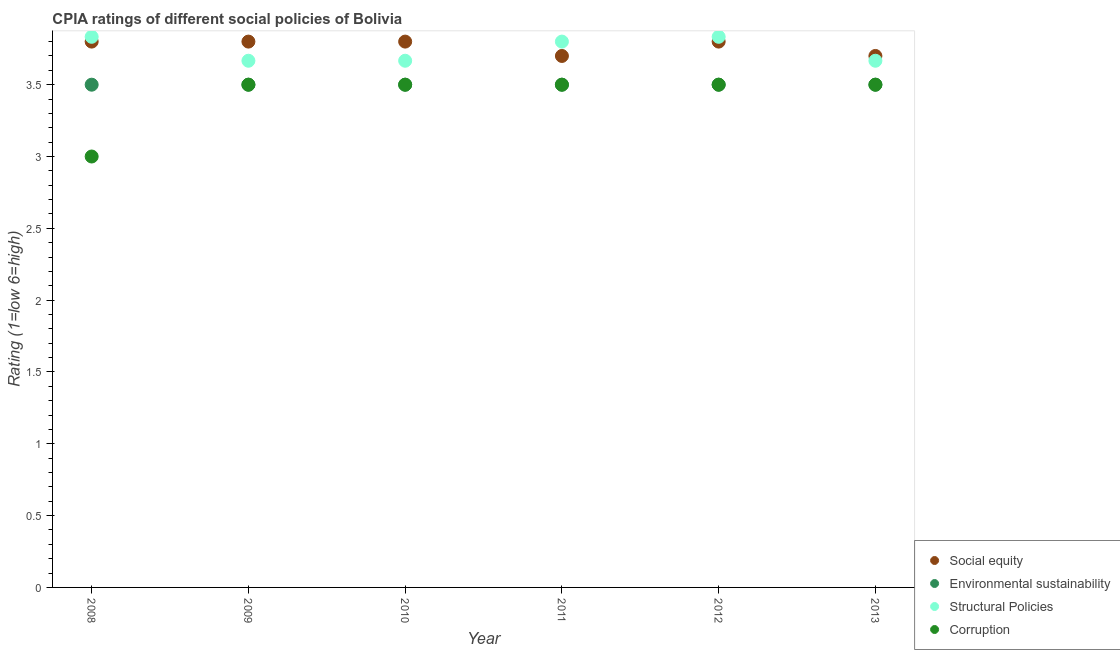Is the number of dotlines equal to the number of legend labels?
Your response must be concise. Yes. Across all years, what is the maximum cpia rating of social equity?
Keep it short and to the point. 3.8. What is the total cpia rating of environmental sustainability in the graph?
Your answer should be compact. 21. What is the difference between the cpia rating of environmental sustainability in 2011 and that in 2013?
Provide a succinct answer. 0. What is the average cpia rating of structural policies per year?
Keep it short and to the point. 3.74. In the year 2010, what is the difference between the cpia rating of structural policies and cpia rating of environmental sustainability?
Ensure brevity in your answer.  0.17. In how many years, is the cpia rating of environmental sustainability greater than 2.5?
Your answer should be compact. 6. What is the ratio of the cpia rating of corruption in 2009 to that in 2011?
Provide a short and direct response. 1. Is the cpia rating of environmental sustainability in 2011 less than that in 2013?
Your response must be concise. No. What is the difference between the highest and the second highest cpia rating of environmental sustainability?
Make the answer very short. 0. In how many years, is the cpia rating of corruption greater than the average cpia rating of corruption taken over all years?
Your answer should be compact. 5. Is the sum of the cpia rating of corruption in 2008 and 2012 greater than the maximum cpia rating of social equity across all years?
Keep it short and to the point. Yes. Is it the case that in every year, the sum of the cpia rating of environmental sustainability and cpia rating of structural policies is greater than the sum of cpia rating of corruption and cpia rating of social equity?
Offer a very short reply. No. Is the cpia rating of environmental sustainability strictly greater than the cpia rating of social equity over the years?
Offer a very short reply. No. Is the cpia rating of social equity strictly less than the cpia rating of structural policies over the years?
Your response must be concise. No. How many years are there in the graph?
Your response must be concise. 6. What is the difference between two consecutive major ticks on the Y-axis?
Offer a very short reply. 0.5. Does the graph contain any zero values?
Make the answer very short. No. Does the graph contain grids?
Give a very brief answer. No. How are the legend labels stacked?
Your answer should be compact. Vertical. What is the title of the graph?
Keep it short and to the point. CPIA ratings of different social policies of Bolivia. Does "Primary schools" appear as one of the legend labels in the graph?
Ensure brevity in your answer.  No. What is the Rating (1=low 6=high) in Social equity in 2008?
Provide a succinct answer. 3.8. What is the Rating (1=low 6=high) of Structural Policies in 2008?
Make the answer very short. 3.83. What is the Rating (1=low 6=high) of Social equity in 2009?
Offer a very short reply. 3.8. What is the Rating (1=low 6=high) of Environmental sustainability in 2009?
Make the answer very short. 3.5. What is the Rating (1=low 6=high) in Structural Policies in 2009?
Offer a very short reply. 3.67. What is the Rating (1=low 6=high) in Structural Policies in 2010?
Your response must be concise. 3.67. What is the Rating (1=low 6=high) in Social equity in 2011?
Provide a short and direct response. 3.7. What is the Rating (1=low 6=high) of Environmental sustainability in 2011?
Ensure brevity in your answer.  3.5. What is the Rating (1=low 6=high) in Social equity in 2012?
Your answer should be very brief. 3.8. What is the Rating (1=low 6=high) of Structural Policies in 2012?
Ensure brevity in your answer.  3.83. What is the Rating (1=low 6=high) of Environmental sustainability in 2013?
Keep it short and to the point. 3.5. What is the Rating (1=low 6=high) in Structural Policies in 2013?
Provide a short and direct response. 3.67. Across all years, what is the maximum Rating (1=low 6=high) of Social equity?
Your answer should be very brief. 3.8. Across all years, what is the maximum Rating (1=low 6=high) in Structural Policies?
Provide a short and direct response. 3.83. Across all years, what is the minimum Rating (1=low 6=high) of Structural Policies?
Provide a succinct answer. 3.67. What is the total Rating (1=low 6=high) of Social equity in the graph?
Your answer should be very brief. 22.6. What is the total Rating (1=low 6=high) in Environmental sustainability in the graph?
Your answer should be compact. 21. What is the total Rating (1=low 6=high) in Structural Policies in the graph?
Provide a succinct answer. 22.47. What is the total Rating (1=low 6=high) in Corruption in the graph?
Keep it short and to the point. 20.5. What is the difference between the Rating (1=low 6=high) in Corruption in 2008 and that in 2009?
Provide a short and direct response. -0.5. What is the difference between the Rating (1=low 6=high) in Corruption in 2008 and that in 2010?
Make the answer very short. -0.5. What is the difference between the Rating (1=low 6=high) in Environmental sustainability in 2008 and that in 2011?
Make the answer very short. 0. What is the difference between the Rating (1=low 6=high) of Environmental sustainability in 2008 and that in 2012?
Offer a terse response. 0. What is the difference between the Rating (1=low 6=high) in Structural Policies in 2008 and that in 2012?
Offer a very short reply. 0. What is the difference between the Rating (1=low 6=high) in Social equity in 2008 and that in 2013?
Provide a short and direct response. 0.1. What is the difference between the Rating (1=low 6=high) of Environmental sustainability in 2008 and that in 2013?
Give a very brief answer. 0. What is the difference between the Rating (1=low 6=high) of Structural Policies in 2009 and that in 2010?
Ensure brevity in your answer.  0. What is the difference between the Rating (1=low 6=high) of Corruption in 2009 and that in 2010?
Your response must be concise. 0. What is the difference between the Rating (1=low 6=high) in Social equity in 2009 and that in 2011?
Offer a terse response. 0.1. What is the difference between the Rating (1=low 6=high) of Environmental sustainability in 2009 and that in 2011?
Ensure brevity in your answer.  0. What is the difference between the Rating (1=low 6=high) in Structural Policies in 2009 and that in 2011?
Provide a short and direct response. -0.13. What is the difference between the Rating (1=low 6=high) of Corruption in 2009 and that in 2012?
Give a very brief answer. 0. What is the difference between the Rating (1=low 6=high) of Structural Policies in 2009 and that in 2013?
Your answer should be very brief. 0. What is the difference between the Rating (1=low 6=high) in Corruption in 2009 and that in 2013?
Your response must be concise. 0. What is the difference between the Rating (1=low 6=high) of Social equity in 2010 and that in 2011?
Provide a short and direct response. 0.1. What is the difference between the Rating (1=low 6=high) of Environmental sustainability in 2010 and that in 2011?
Your answer should be very brief. 0. What is the difference between the Rating (1=low 6=high) in Structural Policies in 2010 and that in 2011?
Your answer should be very brief. -0.13. What is the difference between the Rating (1=low 6=high) in Corruption in 2010 and that in 2011?
Keep it short and to the point. 0. What is the difference between the Rating (1=low 6=high) in Social equity in 2010 and that in 2012?
Your answer should be compact. 0. What is the difference between the Rating (1=low 6=high) of Environmental sustainability in 2010 and that in 2013?
Your answer should be very brief. 0. What is the difference between the Rating (1=low 6=high) in Structural Policies in 2010 and that in 2013?
Your response must be concise. 0. What is the difference between the Rating (1=low 6=high) in Corruption in 2010 and that in 2013?
Offer a terse response. 0. What is the difference between the Rating (1=low 6=high) in Social equity in 2011 and that in 2012?
Your response must be concise. -0.1. What is the difference between the Rating (1=low 6=high) of Structural Policies in 2011 and that in 2012?
Your answer should be very brief. -0.03. What is the difference between the Rating (1=low 6=high) in Corruption in 2011 and that in 2012?
Offer a terse response. 0. What is the difference between the Rating (1=low 6=high) of Environmental sustainability in 2011 and that in 2013?
Keep it short and to the point. 0. What is the difference between the Rating (1=low 6=high) of Structural Policies in 2011 and that in 2013?
Offer a very short reply. 0.13. What is the difference between the Rating (1=low 6=high) of Corruption in 2011 and that in 2013?
Offer a terse response. 0. What is the difference between the Rating (1=low 6=high) in Social equity in 2012 and that in 2013?
Ensure brevity in your answer.  0.1. What is the difference between the Rating (1=low 6=high) of Structural Policies in 2012 and that in 2013?
Provide a short and direct response. 0.17. What is the difference between the Rating (1=low 6=high) in Corruption in 2012 and that in 2013?
Your answer should be compact. 0. What is the difference between the Rating (1=low 6=high) of Social equity in 2008 and the Rating (1=low 6=high) of Structural Policies in 2009?
Provide a short and direct response. 0.13. What is the difference between the Rating (1=low 6=high) in Social equity in 2008 and the Rating (1=low 6=high) in Corruption in 2009?
Your answer should be very brief. 0.3. What is the difference between the Rating (1=low 6=high) of Social equity in 2008 and the Rating (1=low 6=high) of Structural Policies in 2010?
Keep it short and to the point. 0.13. What is the difference between the Rating (1=low 6=high) in Environmental sustainability in 2008 and the Rating (1=low 6=high) in Structural Policies in 2010?
Offer a terse response. -0.17. What is the difference between the Rating (1=low 6=high) in Social equity in 2008 and the Rating (1=low 6=high) in Corruption in 2011?
Ensure brevity in your answer.  0.3. What is the difference between the Rating (1=low 6=high) in Environmental sustainability in 2008 and the Rating (1=low 6=high) in Structural Policies in 2011?
Give a very brief answer. -0.3. What is the difference between the Rating (1=low 6=high) in Environmental sustainability in 2008 and the Rating (1=low 6=high) in Corruption in 2011?
Your answer should be compact. 0. What is the difference between the Rating (1=low 6=high) of Structural Policies in 2008 and the Rating (1=low 6=high) of Corruption in 2011?
Offer a terse response. 0.33. What is the difference between the Rating (1=low 6=high) of Social equity in 2008 and the Rating (1=low 6=high) of Structural Policies in 2012?
Make the answer very short. -0.03. What is the difference between the Rating (1=low 6=high) of Social equity in 2008 and the Rating (1=low 6=high) of Corruption in 2012?
Offer a terse response. 0.3. What is the difference between the Rating (1=low 6=high) in Environmental sustainability in 2008 and the Rating (1=low 6=high) in Structural Policies in 2012?
Make the answer very short. -0.33. What is the difference between the Rating (1=low 6=high) of Environmental sustainability in 2008 and the Rating (1=low 6=high) of Corruption in 2012?
Offer a very short reply. 0. What is the difference between the Rating (1=low 6=high) of Social equity in 2008 and the Rating (1=low 6=high) of Environmental sustainability in 2013?
Offer a terse response. 0.3. What is the difference between the Rating (1=low 6=high) in Social equity in 2008 and the Rating (1=low 6=high) in Structural Policies in 2013?
Your answer should be very brief. 0.13. What is the difference between the Rating (1=low 6=high) of Social equity in 2008 and the Rating (1=low 6=high) of Corruption in 2013?
Make the answer very short. 0.3. What is the difference between the Rating (1=low 6=high) of Environmental sustainability in 2008 and the Rating (1=low 6=high) of Structural Policies in 2013?
Keep it short and to the point. -0.17. What is the difference between the Rating (1=low 6=high) of Environmental sustainability in 2008 and the Rating (1=low 6=high) of Corruption in 2013?
Make the answer very short. 0. What is the difference between the Rating (1=low 6=high) of Social equity in 2009 and the Rating (1=low 6=high) of Environmental sustainability in 2010?
Make the answer very short. 0.3. What is the difference between the Rating (1=low 6=high) of Social equity in 2009 and the Rating (1=low 6=high) of Structural Policies in 2010?
Your answer should be compact. 0.13. What is the difference between the Rating (1=low 6=high) of Social equity in 2009 and the Rating (1=low 6=high) of Corruption in 2010?
Offer a very short reply. 0.3. What is the difference between the Rating (1=low 6=high) in Environmental sustainability in 2009 and the Rating (1=low 6=high) in Structural Policies in 2010?
Offer a terse response. -0.17. What is the difference between the Rating (1=low 6=high) in Environmental sustainability in 2009 and the Rating (1=low 6=high) in Corruption in 2011?
Provide a succinct answer. 0. What is the difference between the Rating (1=low 6=high) in Structural Policies in 2009 and the Rating (1=low 6=high) in Corruption in 2011?
Give a very brief answer. 0.17. What is the difference between the Rating (1=low 6=high) in Social equity in 2009 and the Rating (1=low 6=high) in Environmental sustainability in 2012?
Give a very brief answer. 0.3. What is the difference between the Rating (1=low 6=high) of Social equity in 2009 and the Rating (1=low 6=high) of Structural Policies in 2012?
Provide a short and direct response. -0.03. What is the difference between the Rating (1=low 6=high) of Environmental sustainability in 2009 and the Rating (1=low 6=high) of Structural Policies in 2012?
Offer a terse response. -0.33. What is the difference between the Rating (1=low 6=high) in Environmental sustainability in 2009 and the Rating (1=low 6=high) in Corruption in 2012?
Offer a terse response. 0. What is the difference between the Rating (1=low 6=high) of Social equity in 2009 and the Rating (1=low 6=high) of Environmental sustainability in 2013?
Provide a succinct answer. 0.3. What is the difference between the Rating (1=low 6=high) of Social equity in 2009 and the Rating (1=low 6=high) of Structural Policies in 2013?
Ensure brevity in your answer.  0.13. What is the difference between the Rating (1=low 6=high) of Social equity in 2009 and the Rating (1=low 6=high) of Corruption in 2013?
Provide a succinct answer. 0.3. What is the difference between the Rating (1=low 6=high) of Social equity in 2010 and the Rating (1=low 6=high) of Structural Policies in 2011?
Offer a very short reply. 0. What is the difference between the Rating (1=low 6=high) of Social equity in 2010 and the Rating (1=low 6=high) of Corruption in 2011?
Ensure brevity in your answer.  0.3. What is the difference between the Rating (1=low 6=high) in Structural Policies in 2010 and the Rating (1=low 6=high) in Corruption in 2011?
Give a very brief answer. 0.17. What is the difference between the Rating (1=low 6=high) in Social equity in 2010 and the Rating (1=low 6=high) in Structural Policies in 2012?
Make the answer very short. -0.03. What is the difference between the Rating (1=low 6=high) of Social equity in 2010 and the Rating (1=low 6=high) of Corruption in 2012?
Ensure brevity in your answer.  0.3. What is the difference between the Rating (1=low 6=high) in Environmental sustainability in 2010 and the Rating (1=low 6=high) in Structural Policies in 2012?
Make the answer very short. -0.33. What is the difference between the Rating (1=low 6=high) of Environmental sustainability in 2010 and the Rating (1=low 6=high) of Corruption in 2012?
Keep it short and to the point. 0. What is the difference between the Rating (1=low 6=high) of Social equity in 2010 and the Rating (1=low 6=high) of Structural Policies in 2013?
Offer a very short reply. 0.13. What is the difference between the Rating (1=low 6=high) of Environmental sustainability in 2010 and the Rating (1=low 6=high) of Corruption in 2013?
Offer a terse response. 0. What is the difference between the Rating (1=low 6=high) in Structural Policies in 2010 and the Rating (1=low 6=high) in Corruption in 2013?
Your answer should be very brief. 0.17. What is the difference between the Rating (1=low 6=high) in Social equity in 2011 and the Rating (1=low 6=high) in Structural Policies in 2012?
Offer a very short reply. -0.13. What is the difference between the Rating (1=low 6=high) of Environmental sustainability in 2011 and the Rating (1=low 6=high) of Structural Policies in 2012?
Offer a terse response. -0.33. What is the difference between the Rating (1=low 6=high) in Environmental sustainability in 2011 and the Rating (1=low 6=high) in Corruption in 2012?
Provide a short and direct response. 0. What is the difference between the Rating (1=low 6=high) of Structural Policies in 2011 and the Rating (1=low 6=high) of Corruption in 2012?
Make the answer very short. 0.3. What is the difference between the Rating (1=low 6=high) in Social equity in 2011 and the Rating (1=low 6=high) in Environmental sustainability in 2013?
Give a very brief answer. 0.2. What is the difference between the Rating (1=low 6=high) in Environmental sustainability in 2011 and the Rating (1=low 6=high) in Structural Policies in 2013?
Offer a very short reply. -0.17. What is the difference between the Rating (1=low 6=high) of Social equity in 2012 and the Rating (1=low 6=high) of Structural Policies in 2013?
Provide a succinct answer. 0.13. What is the difference between the Rating (1=low 6=high) in Social equity in 2012 and the Rating (1=low 6=high) in Corruption in 2013?
Your answer should be compact. 0.3. What is the difference between the Rating (1=low 6=high) in Structural Policies in 2012 and the Rating (1=low 6=high) in Corruption in 2013?
Ensure brevity in your answer.  0.33. What is the average Rating (1=low 6=high) in Social equity per year?
Offer a terse response. 3.77. What is the average Rating (1=low 6=high) of Structural Policies per year?
Keep it short and to the point. 3.74. What is the average Rating (1=low 6=high) in Corruption per year?
Make the answer very short. 3.42. In the year 2008, what is the difference between the Rating (1=low 6=high) in Social equity and Rating (1=low 6=high) in Environmental sustainability?
Give a very brief answer. 0.3. In the year 2008, what is the difference between the Rating (1=low 6=high) of Social equity and Rating (1=low 6=high) of Structural Policies?
Your response must be concise. -0.03. In the year 2008, what is the difference between the Rating (1=low 6=high) of Social equity and Rating (1=low 6=high) of Corruption?
Make the answer very short. 0.8. In the year 2008, what is the difference between the Rating (1=low 6=high) in Environmental sustainability and Rating (1=low 6=high) in Structural Policies?
Ensure brevity in your answer.  -0.33. In the year 2008, what is the difference between the Rating (1=low 6=high) of Environmental sustainability and Rating (1=low 6=high) of Corruption?
Provide a short and direct response. 0.5. In the year 2009, what is the difference between the Rating (1=low 6=high) of Social equity and Rating (1=low 6=high) of Structural Policies?
Your answer should be very brief. 0.13. In the year 2009, what is the difference between the Rating (1=low 6=high) of Social equity and Rating (1=low 6=high) of Corruption?
Offer a terse response. 0.3. In the year 2009, what is the difference between the Rating (1=low 6=high) in Environmental sustainability and Rating (1=low 6=high) in Structural Policies?
Keep it short and to the point. -0.17. In the year 2009, what is the difference between the Rating (1=low 6=high) in Environmental sustainability and Rating (1=low 6=high) in Corruption?
Your response must be concise. 0. In the year 2010, what is the difference between the Rating (1=low 6=high) in Social equity and Rating (1=low 6=high) in Environmental sustainability?
Make the answer very short. 0.3. In the year 2010, what is the difference between the Rating (1=low 6=high) in Social equity and Rating (1=low 6=high) in Structural Policies?
Give a very brief answer. 0.13. In the year 2010, what is the difference between the Rating (1=low 6=high) of Environmental sustainability and Rating (1=low 6=high) of Corruption?
Give a very brief answer. 0. In the year 2010, what is the difference between the Rating (1=low 6=high) of Structural Policies and Rating (1=low 6=high) of Corruption?
Offer a very short reply. 0.17. In the year 2011, what is the difference between the Rating (1=low 6=high) in Social equity and Rating (1=low 6=high) in Environmental sustainability?
Offer a very short reply. 0.2. In the year 2011, what is the difference between the Rating (1=low 6=high) in Social equity and Rating (1=low 6=high) in Corruption?
Your answer should be very brief. 0.2. In the year 2012, what is the difference between the Rating (1=low 6=high) in Social equity and Rating (1=low 6=high) in Structural Policies?
Make the answer very short. -0.03. In the year 2012, what is the difference between the Rating (1=low 6=high) of Environmental sustainability and Rating (1=low 6=high) of Corruption?
Ensure brevity in your answer.  0. In the year 2013, what is the difference between the Rating (1=low 6=high) of Social equity and Rating (1=low 6=high) of Environmental sustainability?
Provide a succinct answer. 0.2. In the year 2013, what is the difference between the Rating (1=low 6=high) of Social equity and Rating (1=low 6=high) of Structural Policies?
Your answer should be very brief. 0.03. In the year 2013, what is the difference between the Rating (1=low 6=high) in Social equity and Rating (1=low 6=high) in Corruption?
Provide a short and direct response. 0.2. In the year 2013, what is the difference between the Rating (1=low 6=high) of Environmental sustainability and Rating (1=low 6=high) of Corruption?
Your response must be concise. 0. In the year 2013, what is the difference between the Rating (1=low 6=high) in Structural Policies and Rating (1=low 6=high) in Corruption?
Your answer should be compact. 0.17. What is the ratio of the Rating (1=low 6=high) in Social equity in 2008 to that in 2009?
Provide a short and direct response. 1. What is the ratio of the Rating (1=low 6=high) of Environmental sustainability in 2008 to that in 2009?
Provide a short and direct response. 1. What is the ratio of the Rating (1=low 6=high) in Structural Policies in 2008 to that in 2009?
Make the answer very short. 1.05. What is the ratio of the Rating (1=low 6=high) in Structural Policies in 2008 to that in 2010?
Give a very brief answer. 1.05. What is the ratio of the Rating (1=low 6=high) in Corruption in 2008 to that in 2010?
Your answer should be very brief. 0.86. What is the ratio of the Rating (1=low 6=high) of Social equity in 2008 to that in 2011?
Keep it short and to the point. 1.03. What is the ratio of the Rating (1=low 6=high) in Structural Policies in 2008 to that in 2011?
Your answer should be very brief. 1.01. What is the ratio of the Rating (1=low 6=high) in Social equity in 2008 to that in 2012?
Your answer should be compact. 1. What is the ratio of the Rating (1=low 6=high) of Structural Policies in 2008 to that in 2012?
Offer a very short reply. 1. What is the ratio of the Rating (1=low 6=high) in Corruption in 2008 to that in 2012?
Give a very brief answer. 0.86. What is the ratio of the Rating (1=low 6=high) in Environmental sustainability in 2008 to that in 2013?
Offer a very short reply. 1. What is the ratio of the Rating (1=low 6=high) of Structural Policies in 2008 to that in 2013?
Give a very brief answer. 1.05. What is the ratio of the Rating (1=low 6=high) in Corruption in 2008 to that in 2013?
Give a very brief answer. 0.86. What is the ratio of the Rating (1=low 6=high) in Social equity in 2009 to that in 2010?
Ensure brevity in your answer.  1. What is the ratio of the Rating (1=low 6=high) in Structural Policies in 2009 to that in 2010?
Your answer should be very brief. 1. What is the ratio of the Rating (1=low 6=high) in Corruption in 2009 to that in 2010?
Ensure brevity in your answer.  1. What is the ratio of the Rating (1=low 6=high) of Social equity in 2009 to that in 2011?
Ensure brevity in your answer.  1.03. What is the ratio of the Rating (1=low 6=high) in Structural Policies in 2009 to that in 2011?
Give a very brief answer. 0.96. What is the ratio of the Rating (1=low 6=high) in Environmental sustainability in 2009 to that in 2012?
Provide a short and direct response. 1. What is the ratio of the Rating (1=low 6=high) of Structural Policies in 2009 to that in 2012?
Provide a succinct answer. 0.96. What is the ratio of the Rating (1=low 6=high) in Structural Policies in 2009 to that in 2013?
Your answer should be compact. 1. What is the ratio of the Rating (1=low 6=high) of Corruption in 2009 to that in 2013?
Offer a terse response. 1. What is the ratio of the Rating (1=low 6=high) in Environmental sustainability in 2010 to that in 2011?
Give a very brief answer. 1. What is the ratio of the Rating (1=low 6=high) of Structural Policies in 2010 to that in 2011?
Your answer should be very brief. 0.96. What is the ratio of the Rating (1=low 6=high) of Corruption in 2010 to that in 2011?
Provide a short and direct response. 1. What is the ratio of the Rating (1=low 6=high) in Social equity in 2010 to that in 2012?
Offer a very short reply. 1. What is the ratio of the Rating (1=low 6=high) in Environmental sustainability in 2010 to that in 2012?
Keep it short and to the point. 1. What is the ratio of the Rating (1=low 6=high) in Structural Policies in 2010 to that in 2012?
Ensure brevity in your answer.  0.96. What is the ratio of the Rating (1=low 6=high) of Corruption in 2010 to that in 2012?
Keep it short and to the point. 1. What is the ratio of the Rating (1=low 6=high) in Environmental sustainability in 2010 to that in 2013?
Your answer should be compact. 1. What is the ratio of the Rating (1=low 6=high) in Structural Policies in 2010 to that in 2013?
Provide a short and direct response. 1. What is the ratio of the Rating (1=low 6=high) of Corruption in 2010 to that in 2013?
Ensure brevity in your answer.  1. What is the ratio of the Rating (1=low 6=high) of Social equity in 2011 to that in 2012?
Make the answer very short. 0.97. What is the ratio of the Rating (1=low 6=high) in Environmental sustainability in 2011 to that in 2012?
Your response must be concise. 1. What is the ratio of the Rating (1=low 6=high) in Corruption in 2011 to that in 2012?
Make the answer very short. 1. What is the ratio of the Rating (1=low 6=high) of Environmental sustainability in 2011 to that in 2013?
Your answer should be compact. 1. What is the ratio of the Rating (1=low 6=high) in Structural Policies in 2011 to that in 2013?
Make the answer very short. 1.04. What is the ratio of the Rating (1=low 6=high) in Corruption in 2011 to that in 2013?
Provide a succinct answer. 1. What is the ratio of the Rating (1=low 6=high) in Structural Policies in 2012 to that in 2013?
Keep it short and to the point. 1.05. What is the difference between the highest and the second highest Rating (1=low 6=high) in Social equity?
Your answer should be compact. 0. What is the difference between the highest and the second highest Rating (1=low 6=high) of Corruption?
Give a very brief answer. 0. What is the difference between the highest and the lowest Rating (1=low 6=high) in Environmental sustainability?
Your answer should be very brief. 0. 